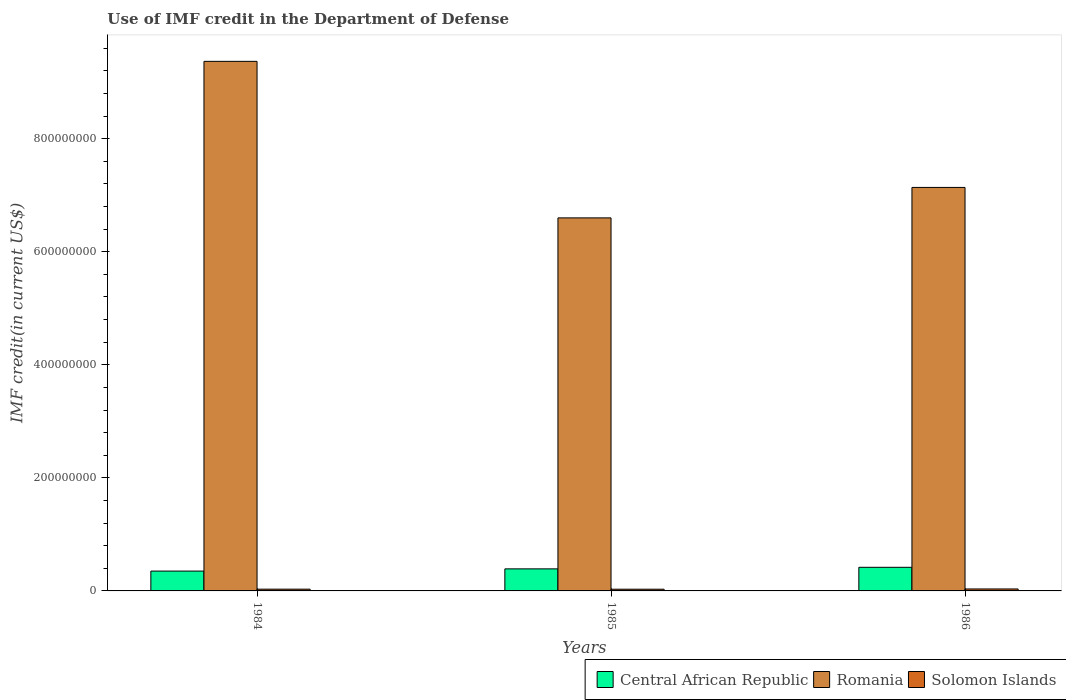How many groups of bars are there?
Your answer should be compact. 3. How many bars are there on the 2nd tick from the left?
Keep it short and to the point. 3. How many bars are there on the 3rd tick from the right?
Give a very brief answer. 3. What is the IMF credit in the Department of Defense in Romania in 1985?
Keep it short and to the point. 6.60e+08. Across all years, what is the maximum IMF credit in the Department of Defense in Solomon Islands?
Keep it short and to the point. 3.46e+06. Across all years, what is the minimum IMF credit in the Department of Defense in Central African Republic?
Your answer should be compact. 3.51e+07. In which year was the IMF credit in the Department of Defense in Solomon Islands minimum?
Your answer should be very brief. 1985. What is the total IMF credit in the Department of Defense in Central African Republic in the graph?
Give a very brief answer. 1.16e+08. What is the difference between the IMF credit in the Department of Defense in Central African Republic in 1985 and that in 1986?
Give a very brief answer. -2.78e+06. What is the difference between the IMF credit in the Department of Defense in Romania in 1986 and the IMF credit in the Department of Defense in Central African Republic in 1984?
Keep it short and to the point. 6.79e+08. What is the average IMF credit in the Department of Defense in Solomon Islands per year?
Your answer should be compact. 3.20e+06. In the year 1986, what is the difference between the IMF credit in the Department of Defense in Romania and IMF credit in the Department of Defense in Central African Republic?
Offer a very short reply. 6.72e+08. In how many years, is the IMF credit in the Department of Defense in Romania greater than 280000000 US$?
Your answer should be very brief. 3. What is the ratio of the IMF credit in the Department of Defense in Romania in 1985 to that in 1986?
Make the answer very short. 0.92. Is the IMF credit in the Department of Defense in Central African Republic in 1984 less than that in 1986?
Provide a succinct answer. Yes. What is the difference between the highest and the second highest IMF credit in the Department of Defense in Central African Republic?
Make the answer very short. 2.78e+06. In how many years, is the IMF credit in the Department of Defense in Central African Republic greater than the average IMF credit in the Department of Defense in Central African Republic taken over all years?
Provide a succinct answer. 2. Is the sum of the IMF credit in the Department of Defense in Romania in 1985 and 1986 greater than the maximum IMF credit in the Department of Defense in Central African Republic across all years?
Give a very brief answer. Yes. What does the 3rd bar from the left in 1985 represents?
Provide a succinct answer. Solomon Islands. What does the 1st bar from the right in 1984 represents?
Make the answer very short. Solomon Islands. Is it the case that in every year, the sum of the IMF credit in the Department of Defense in Romania and IMF credit in the Department of Defense in Central African Republic is greater than the IMF credit in the Department of Defense in Solomon Islands?
Your answer should be compact. Yes. How many bars are there?
Make the answer very short. 9. What is the difference between two consecutive major ticks on the Y-axis?
Keep it short and to the point. 2.00e+08. Are the values on the major ticks of Y-axis written in scientific E-notation?
Ensure brevity in your answer.  No. How many legend labels are there?
Keep it short and to the point. 3. What is the title of the graph?
Your response must be concise. Use of IMF credit in the Department of Defense. What is the label or title of the Y-axis?
Give a very brief answer. IMF credit(in current US$). What is the IMF credit(in current US$) of Central African Republic in 1984?
Make the answer very short. 3.51e+07. What is the IMF credit(in current US$) of Romania in 1984?
Give a very brief answer. 9.37e+08. What is the IMF credit(in current US$) of Solomon Islands in 1984?
Offer a terse response. 3.10e+06. What is the IMF credit(in current US$) of Central African Republic in 1985?
Offer a very short reply. 3.90e+07. What is the IMF credit(in current US$) of Romania in 1985?
Offer a terse response. 6.60e+08. What is the IMF credit(in current US$) of Solomon Islands in 1985?
Provide a succinct answer. 3.03e+06. What is the IMF credit(in current US$) in Central African Republic in 1986?
Make the answer very short. 4.18e+07. What is the IMF credit(in current US$) of Romania in 1986?
Your response must be concise. 7.14e+08. What is the IMF credit(in current US$) in Solomon Islands in 1986?
Your answer should be very brief. 3.46e+06. Across all years, what is the maximum IMF credit(in current US$) in Central African Republic?
Provide a succinct answer. 4.18e+07. Across all years, what is the maximum IMF credit(in current US$) in Romania?
Your answer should be compact. 9.37e+08. Across all years, what is the maximum IMF credit(in current US$) in Solomon Islands?
Offer a very short reply. 3.46e+06. Across all years, what is the minimum IMF credit(in current US$) in Central African Republic?
Your answer should be very brief. 3.51e+07. Across all years, what is the minimum IMF credit(in current US$) in Romania?
Offer a very short reply. 6.60e+08. Across all years, what is the minimum IMF credit(in current US$) in Solomon Islands?
Keep it short and to the point. 3.03e+06. What is the total IMF credit(in current US$) in Central African Republic in the graph?
Keep it short and to the point. 1.16e+08. What is the total IMF credit(in current US$) of Romania in the graph?
Give a very brief answer. 2.31e+09. What is the total IMF credit(in current US$) of Solomon Islands in the graph?
Offer a very short reply. 9.59e+06. What is the difference between the IMF credit(in current US$) of Central African Republic in 1984 and that in 1985?
Keep it short and to the point. -3.94e+06. What is the difference between the IMF credit(in current US$) in Romania in 1984 and that in 1985?
Offer a very short reply. 2.77e+08. What is the difference between the IMF credit(in current US$) in Central African Republic in 1984 and that in 1986?
Your answer should be compact. -6.71e+06. What is the difference between the IMF credit(in current US$) in Romania in 1984 and that in 1986?
Provide a short and direct response. 2.23e+08. What is the difference between the IMF credit(in current US$) in Solomon Islands in 1984 and that in 1986?
Offer a terse response. -3.60e+05. What is the difference between the IMF credit(in current US$) of Central African Republic in 1985 and that in 1986?
Ensure brevity in your answer.  -2.78e+06. What is the difference between the IMF credit(in current US$) of Romania in 1985 and that in 1986?
Ensure brevity in your answer.  -5.39e+07. What is the difference between the IMF credit(in current US$) of Solomon Islands in 1985 and that in 1986?
Give a very brief answer. -4.30e+05. What is the difference between the IMF credit(in current US$) of Central African Republic in 1984 and the IMF credit(in current US$) of Romania in 1985?
Provide a short and direct response. -6.25e+08. What is the difference between the IMF credit(in current US$) in Central African Republic in 1984 and the IMF credit(in current US$) in Solomon Islands in 1985?
Offer a terse response. 3.20e+07. What is the difference between the IMF credit(in current US$) in Romania in 1984 and the IMF credit(in current US$) in Solomon Islands in 1985?
Provide a succinct answer. 9.34e+08. What is the difference between the IMF credit(in current US$) in Central African Republic in 1984 and the IMF credit(in current US$) in Romania in 1986?
Offer a terse response. -6.79e+08. What is the difference between the IMF credit(in current US$) in Central African Republic in 1984 and the IMF credit(in current US$) in Solomon Islands in 1986?
Provide a short and direct response. 3.16e+07. What is the difference between the IMF credit(in current US$) in Romania in 1984 and the IMF credit(in current US$) in Solomon Islands in 1986?
Make the answer very short. 9.33e+08. What is the difference between the IMF credit(in current US$) in Central African Republic in 1985 and the IMF credit(in current US$) in Romania in 1986?
Your response must be concise. -6.75e+08. What is the difference between the IMF credit(in current US$) in Central African Republic in 1985 and the IMF credit(in current US$) in Solomon Islands in 1986?
Make the answer very short. 3.56e+07. What is the difference between the IMF credit(in current US$) in Romania in 1985 and the IMF credit(in current US$) in Solomon Islands in 1986?
Offer a very short reply. 6.56e+08. What is the average IMF credit(in current US$) in Central African Republic per year?
Your answer should be very brief. 3.86e+07. What is the average IMF credit(in current US$) of Romania per year?
Give a very brief answer. 7.70e+08. What is the average IMF credit(in current US$) of Solomon Islands per year?
Offer a terse response. 3.20e+06. In the year 1984, what is the difference between the IMF credit(in current US$) of Central African Republic and IMF credit(in current US$) of Romania?
Your answer should be very brief. -9.02e+08. In the year 1984, what is the difference between the IMF credit(in current US$) of Central African Republic and IMF credit(in current US$) of Solomon Islands?
Provide a short and direct response. 3.20e+07. In the year 1984, what is the difference between the IMF credit(in current US$) of Romania and IMF credit(in current US$) of Solomon Islands?
Your response must be concise. 9.34e+08. In the year 1985, what is the difference between the IMF credit(in current US$) in Central African Republic and IMF credit(in current US$) in Romania?
Make the answer very short. -6.21e+08. In the year 1985, what is the difference between the IMF credit(in current US$) of Central African Republic and IMF credit(in current US$) of Solomon Islands?
Offer a terse response. 3.60e+07. In the year 1985, what is the difference between the IMF credit(in current US$) in Romania and IMF credit(in current US$) in Solomon Islands?
Provide a short and direct response. 6.57e+08. In the year 1986, what is the difference between the IMF credit(in current US$) of Central African Republic and IMF credit(in current US$) of Romania?
Your answer should be very brief. -6.72e+08. In the year 1986, what is the difference between the IMF credit(in current US$) in Central African Republic and IMF credit(in current US$) in Solomon Islands?
Ensure brevity in your answer.  3.83e+07. In the year 1986, what is the difference between the IMF credit(in current US$) of Romania and IMF credit(in current US$) of Solomon Islands?
Provide a succinct answer. 7.10e+08. What is the ratio of the IMF credit(in current US$) in Central African Republic in 1984 to that in 1985?
Provide a succinct answer. 0.9. What is the ratio of the IMF credit(in current US$) of Romania in 1984 to that in 1985?
Ensure brevity in your answer.  1.42. What is the ratio of the IMF credit(in current US$) in Solomon Islands in 1984 to that in 1985?
Offer a very short reply. 1.02. What is the ratio of the IMF credit(in current US$) in Central African Republic in 1984 to that in 1986?
Ensure brevity in your answer.  0.84. What is the ratio of the IMF credit(in current US$) of Romania in 1984 to that in 1986?
Make the answer very short. 1.31. What is the ratio of the IMF credit(in current US$) in Solomon Islands in 1984 to that in 1986?
Give a very brief answer. 0.9. What is the ratio of the IMF credit(in current US$) in Central African Republic in 1985 to that in 1986?
Make the answer very short. 0.93. What is the ratio of the IMF credit(in current US$) of Romania in 1985 to that in 1986?
Ensure brevity in your answer.  0.92. What is the ratio of the IMF credit(in current US$) in Solomon Islands in 1985 to that in 1986?
Keep it short and to the point. 0.88. What is the difference between the highest and the second highest IMF credit(in current US$) of Central African Republic?
Your answer should be compact. 2.78e+06. What is the difference between the highest and the second highest IMF credit(in current US$) of Romania?
Ensure brevity in your answer.  2.23e+08. What is the difference between the highest and the second highest IMF credit(in current US$) of Solomon Islands?
Keep it short and to the point. 3.60e+05. What is the difference between the highest and the lowest IMF credit(in current US$) in Central African Republic?
Ensure brevity in your answer.  6.71e+06. What is the difference between the highest and the lowest IMF credit(in current US$) of Romania?
Your answer should be very brief. 2.77e+08. What is the difference between the highest and the lowest IMF credit(in current US$) in Solomon Islands?
Your answer should be compact. 4.30e+05. 